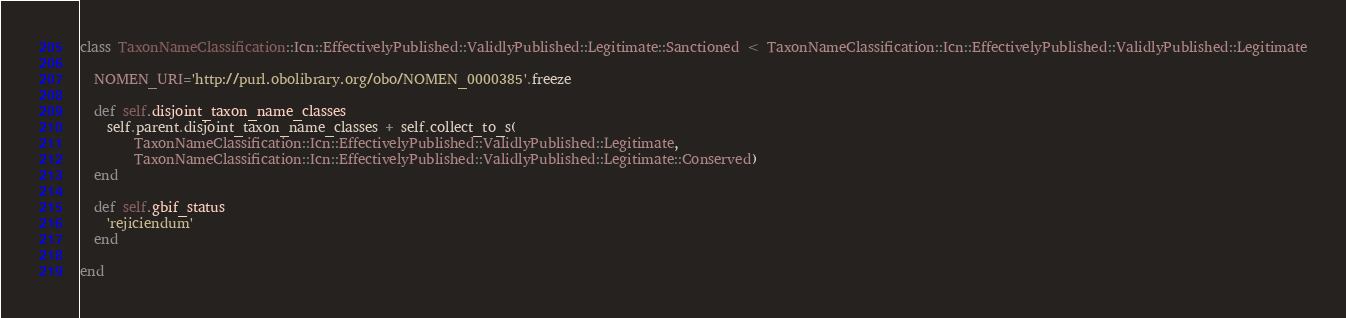<code> <loc_0><loc_0><loc_500><loc_500><_Ruby_>class TaxonNameClassification::Icn::EffectivelyPublished::ValidlyPublished::Legitimate::Sanctioned < TaxonNameClassification::Icn::EffectivelyPublished::ValidlyPublished::Legitimate

  NOMEN_URI='http://purl.obolibrary.org/obo/NOMEN_0000385'.freeze

  def self.disjoint_taxon_name_classes
    self.parent.disjoint_taxon_name_classes + self.collect_to_s(
        TaxonNameClassification::Icn::EffectivelyPublished::ValidlyPublished::Legitimate,
        TaxonNameClassification::Icn::EffectivelyPublished::ValidlyPublished::Legitimate::Conserved)
  end

  def self.gbif_status
    'rejiciendum'
  end

end
</code> 